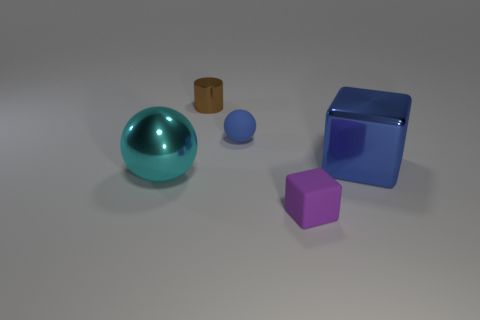Do the metallic sphere and the blue ball have the same size?
Make the answer very short. No. How many things are either big metallic objects or large things on the left side of the small shiny cylinder?
Your answer should be compact. 2. What color is the matte thing that is on the left side of the rubber thing right of the tiny blue rubber object?
Ensure brevity in your answer.  Blue. Is the color of the cube that is behind the purple cube the same as the tiny sphere?
Provide a short and direct response. Yes. What is the blue object to the left of the metallic cube made of?
Your answer should be very brief. Rubber. The blue metallic object is what size?
Provide a short and direct response. Large. Is the material of the small thing in front of the blue cube the same as the small blue ball?
Your response must be concise. Yes. What number of red shiny blocks are there?
Provide a succinct answer. 0. What number of objects are either tiny cylinders or gray balls?
Your answer should be compact. 1. What number of large blue shiny cubes are behind the block that is in front of the metallic object that is to the right of the brown cylinder?
Keep it short and to the point. 1. 